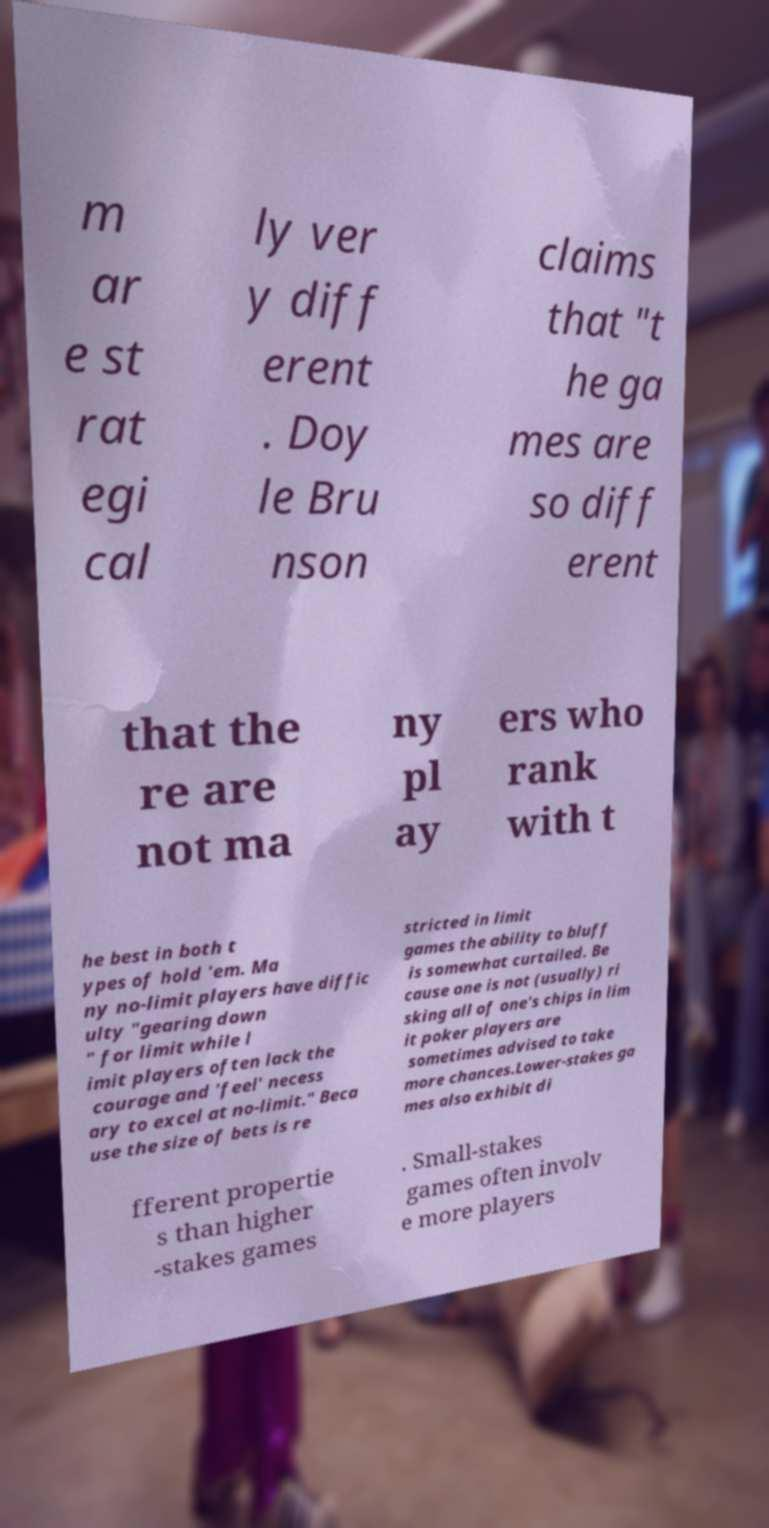Please read and relay the text visible in this image. What does it say? m ar e st rat egi cal ly ver y diff erent . Doy le Bru nson claims that "t he ga mes are so diff erent that the re are not ma ny pl ay ers who rank with t he best in both t ypes of hold 'em. Ma ny no-limit players have diffic ulty "gearing down " for limit while l imit players often lack the courage and 'feel' necess ary to excel at no-limit." Beca use the size of bets is re stricted in limit games the ability to bluff is somewhat curtailed. Be cause one is not (usually) ri sking all of one's chips in lim it poker players are sometimes advised to take more chances.Lower-stakes ga mes also exhibit di fferent propertie s than higher -stakes games . Small-stakes games often involv e more players 